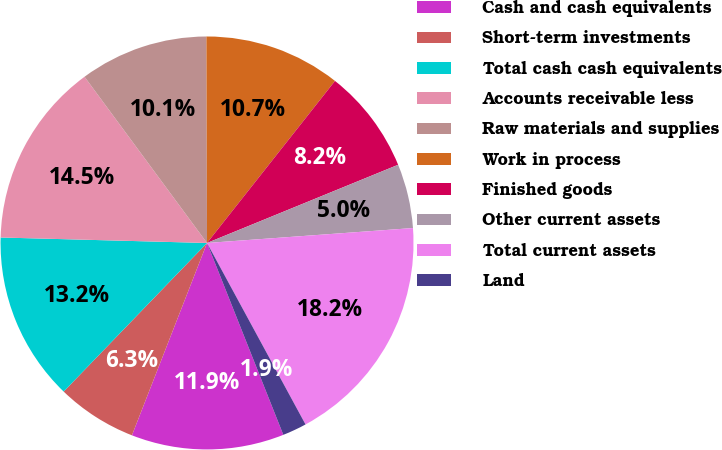<chart> <loc_0><loc_0><loc_500><loc_500><pie_chart><fcel>Cash and cash equivalents<fcel>Short-term investments<fcel>Total cash cash equivalents<fcel>Accounts receivable less<fcel>Raw materials and supplies<fcel>Work in process<fcel>Finished goods<fcel>Other current assets<fcel>Total current assets<fcel>Land<nl><fcel>11.95%<fcel>6.29%<fcel>13.21%<fcel>14.47%<fcel>10.06%<fcel>10.69%<fcel>8.18%<fcel>5.03%<fcel>18.24%<fcel>1.89%<nl></chart> 